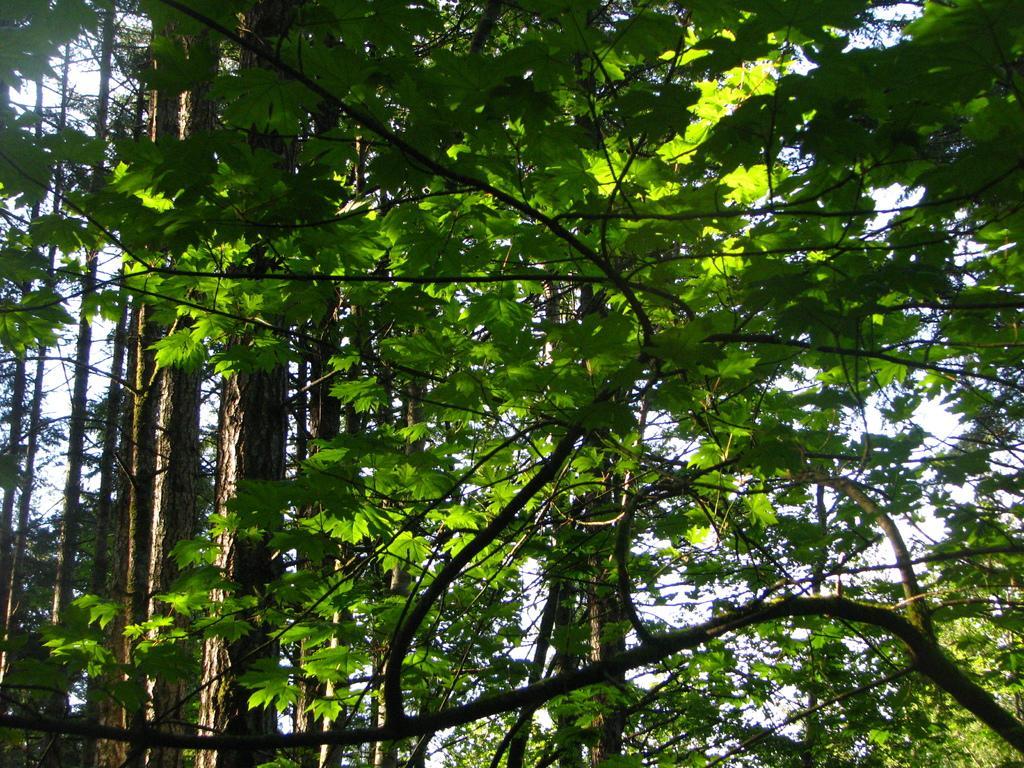Please provide a concise description of this image. This picture is clicked outside. In the center we can see the trees and the sky. 